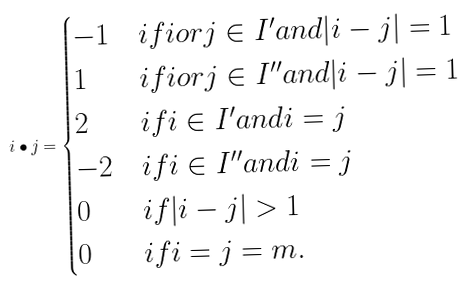<formula> <loc_0><loc_0><loc_500><loc_500>i \bullet j = \begin{cases} - 1 & i f i o r j \in I ^ { \prime } a n d | i - j | = 1 \\ 1 & i f i o r j \in I ^ { \prime \prime } a n d | i - j | = 1 \\ 2 & i f i \in I ^ { \prime } a n d i = j \\ - 2 & i f i \in I ^ { \prime \prime } a n d i = j \\ 0 & i f | i - j | > 1 \\ 0 & i f i = j = m . \end{cases}</formula> 